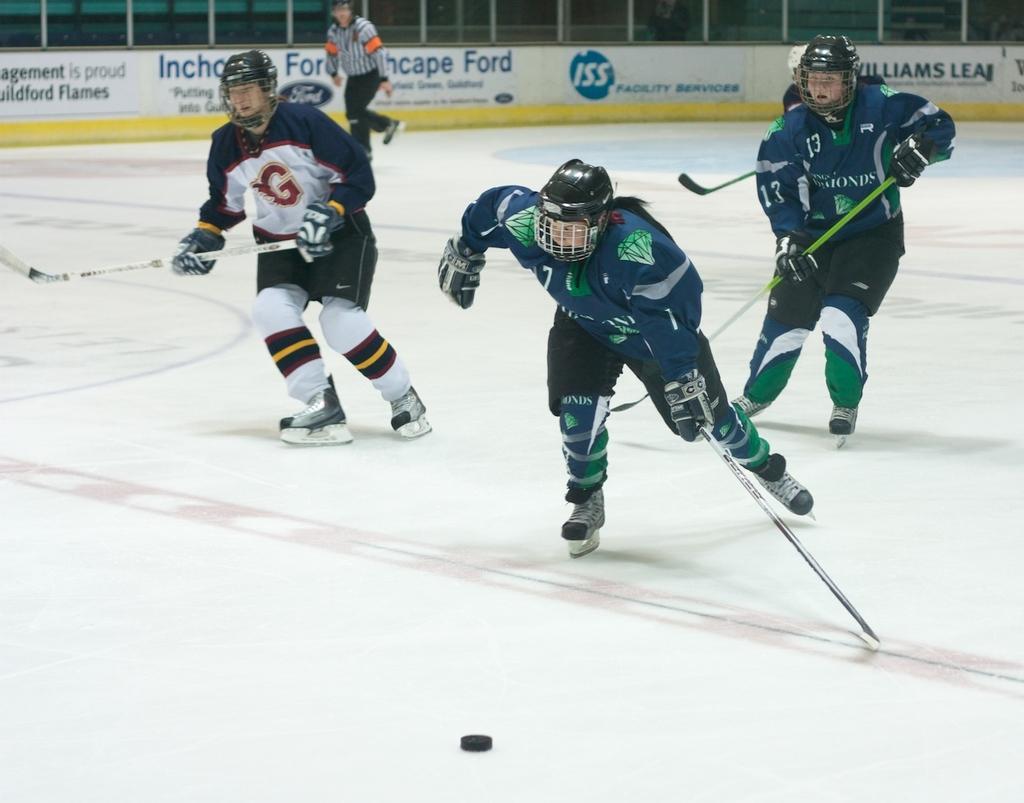Please provide a concise description of this image. There are four persons in different color dresses, holding sticks and playing on the court. In the background, there is another person running, there is a white color hoarding and there are other objects. 